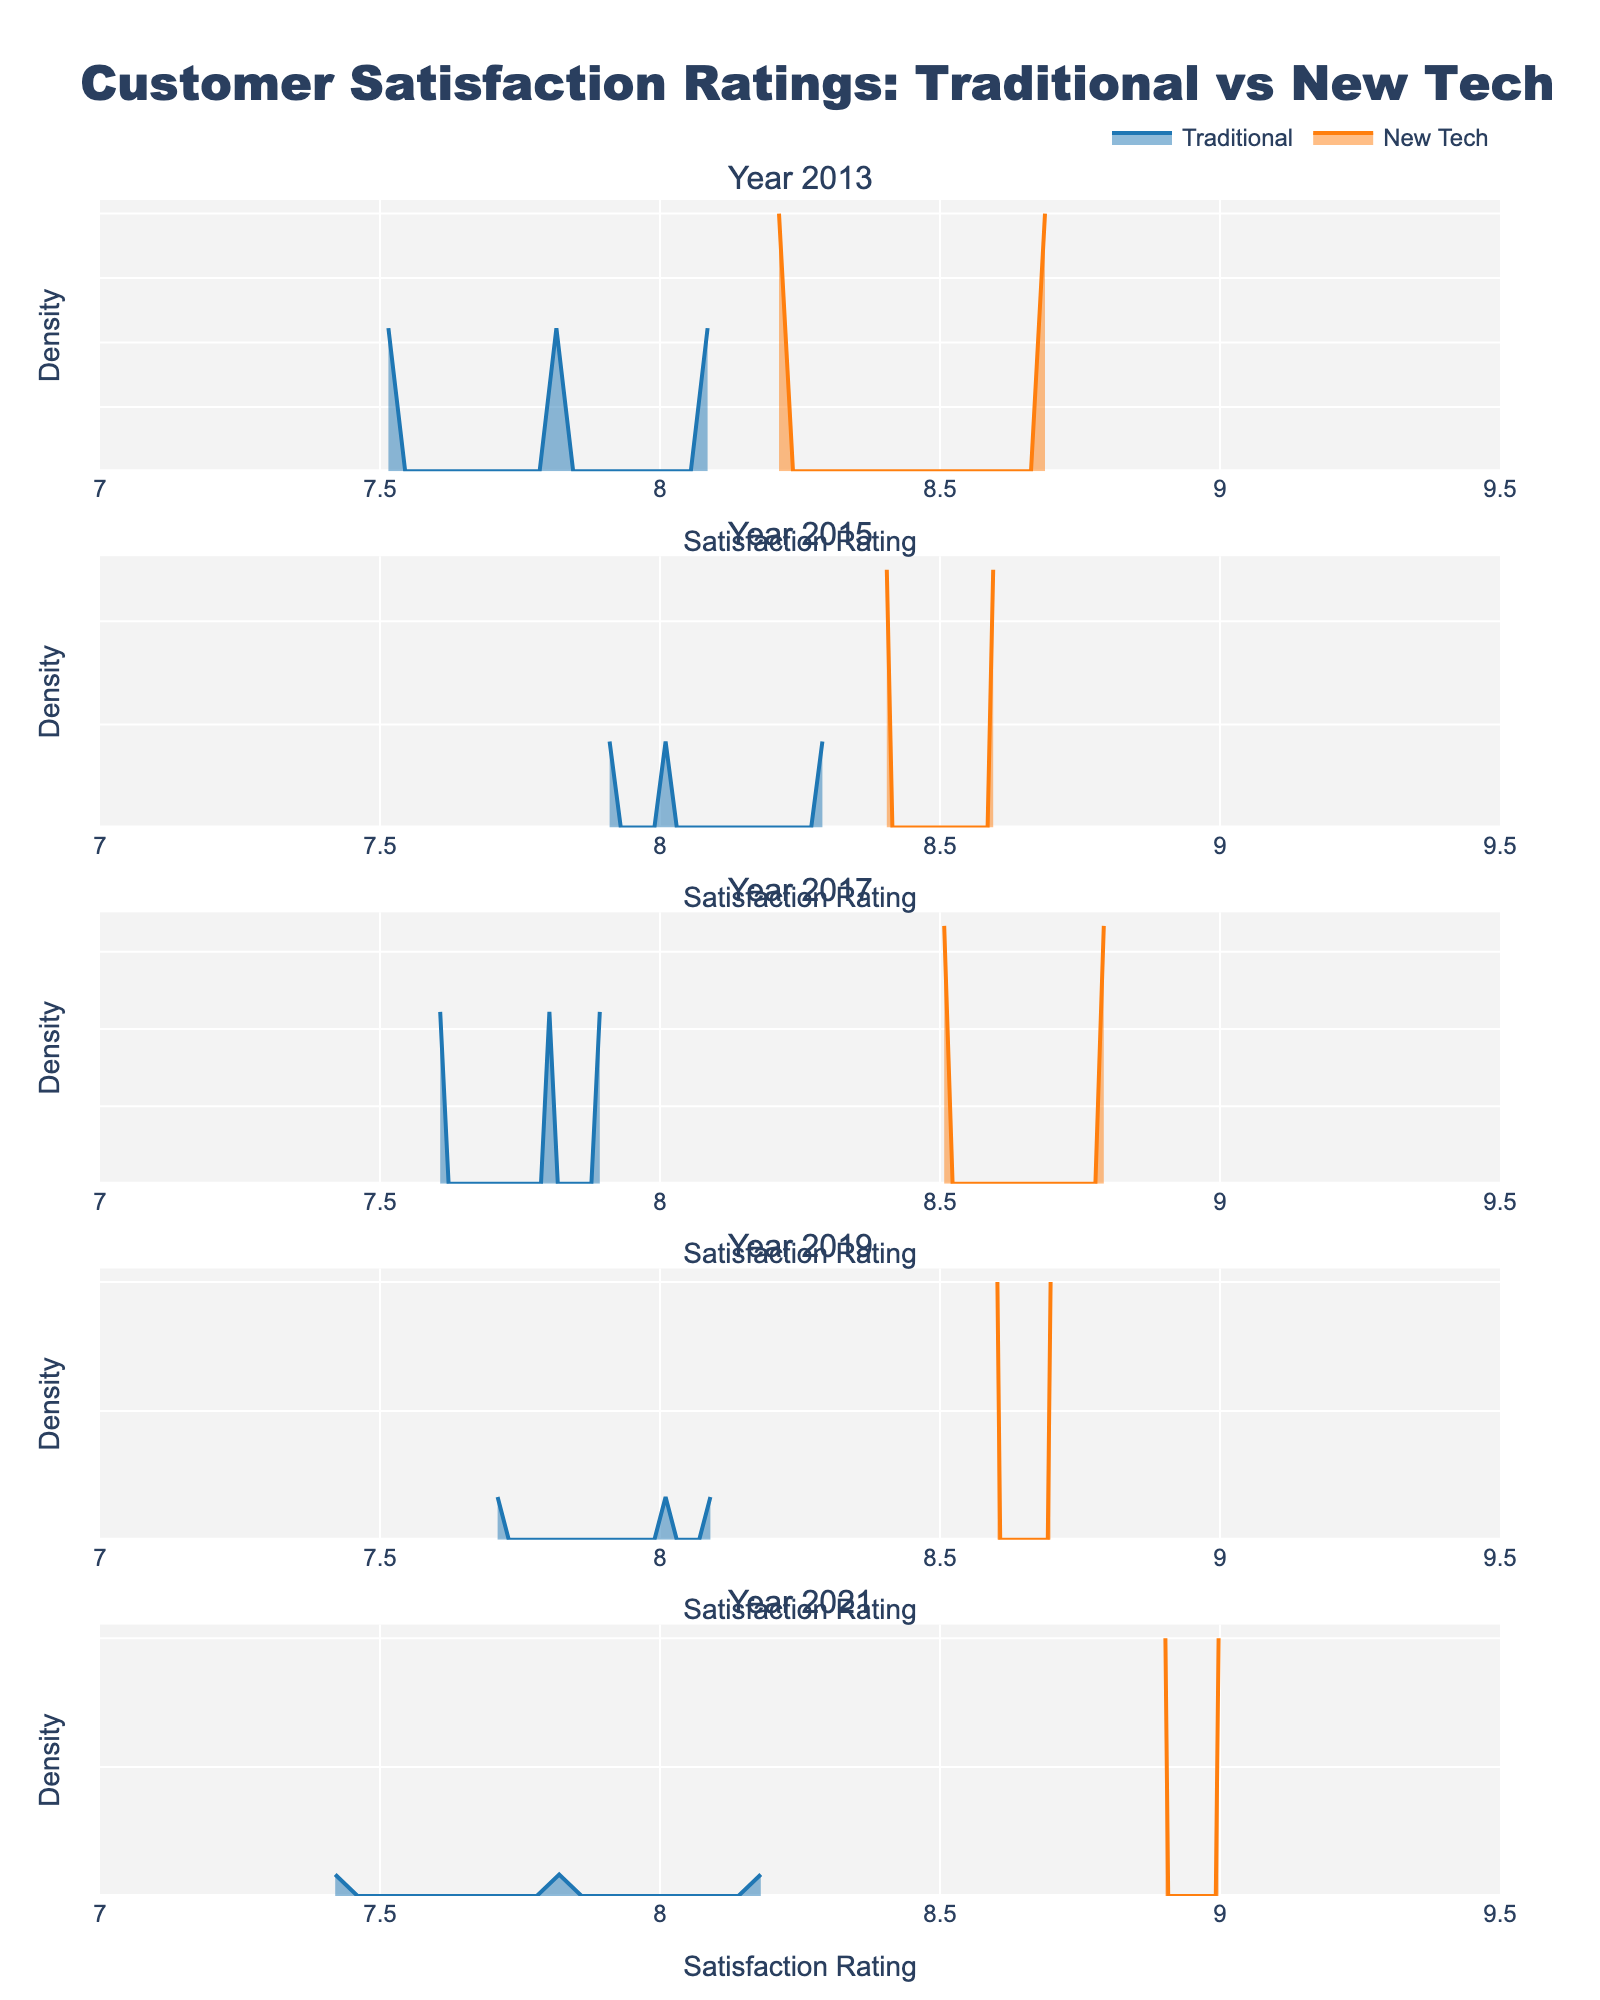Who seems to have higher customer satisfaction ratings in 2013, Traditional or New Tech? Comparing the densities in the 2013 subplot, the New Tech category shows a higher peak around the 8.5 region compared to Traditional, which has peaks around 7.5 to 8.0.
Answer: New Tech What is the range of satisfaction ratings displayed on the X-axis? The X-axis in each subplot ranges from 7 to 9.5 as indicated by its limits.
Answer: 7 to 9.5 Which year has the highest density peak for New Tech products? Observing the density peaks for New Tech products across the subplots, the highest density is seen in 2021 with a peak close to 9.0.
Answer: 2021 Are the densities for Traditional products more spread out or clustered compared to New Tech products in 2019? In 2019, the density for Traditional products is more clustered around the 8.0 rating, whereas New Tech products have a wider spread, peaking near 8.7 but also showing considerable density from 8.0 to 8.6.
Answer: More clustered Which year shows the smallest difference in satisfaction ratings between Traditional and New Tech categories? The subplot for 2015 shows overlapping densities between Traditional and New Tech categories, indicating minimal differences in satisfaction ratings compared to other years.
Answer: 2015 What do the colors represent in these plots? The colors represent different categories: blue for Traditional products and orange for New Tech products.
Answer: Categories How do satisfaction ratings for Traditional products in 2013 compare to those in 2019? Comparing the 2013 and 2019 subplots, Traditional products show a slight increase in density peaks from around 7.8 in 2013 to around 8.0 in 2019.
Answer: Slight increase In which year did the New Tech category have a noticeable increase in satisfaction ratings compared to the previous years? The subplot for 2017 shows a noticeable increase in the density peak of New Tech products around 8.5, significantly higher compared to previous years.
Answer: 2017 What general trend can be observed in satisfaction ratings for New Tech products over the given period? Over the years, there is a visible upward trend in the density peaks for New Tech products, indicating increasing customer satisfaction ratings.
Answer: Increasing trend Between Traditional and New Tech categories, which one has generally higher satisfaction ratings overall across the years? Across all subplots, New Tech consistently shows higher density peaks, indicating higher customer satisfaction ratings overall compared to Traditional.
Answer: New Tech 